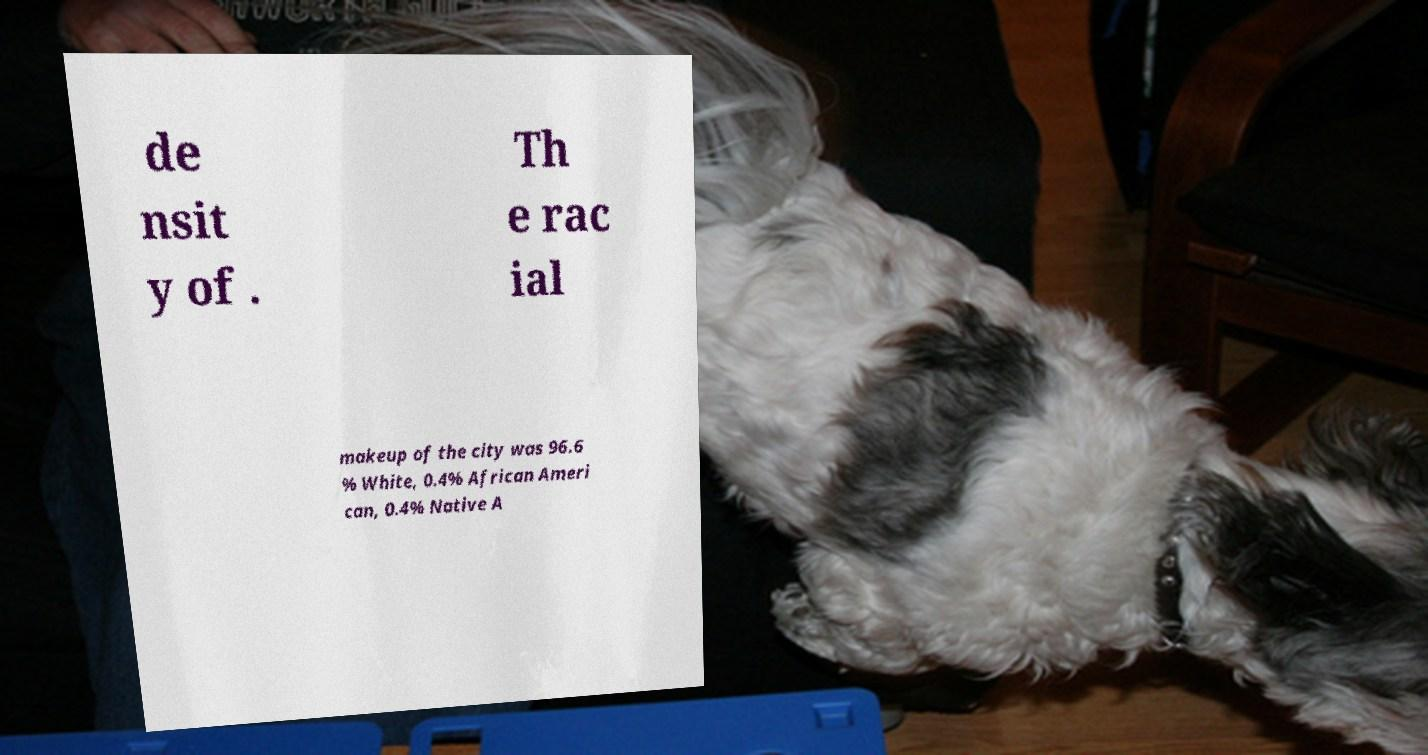For documentation purposes, I need the text within this image transcribed. Could you provide that? de nsit y of . Th e rac ial makeup of the city was 96.6 % White, 0.4% African Ameri can, 0.4% Native A 